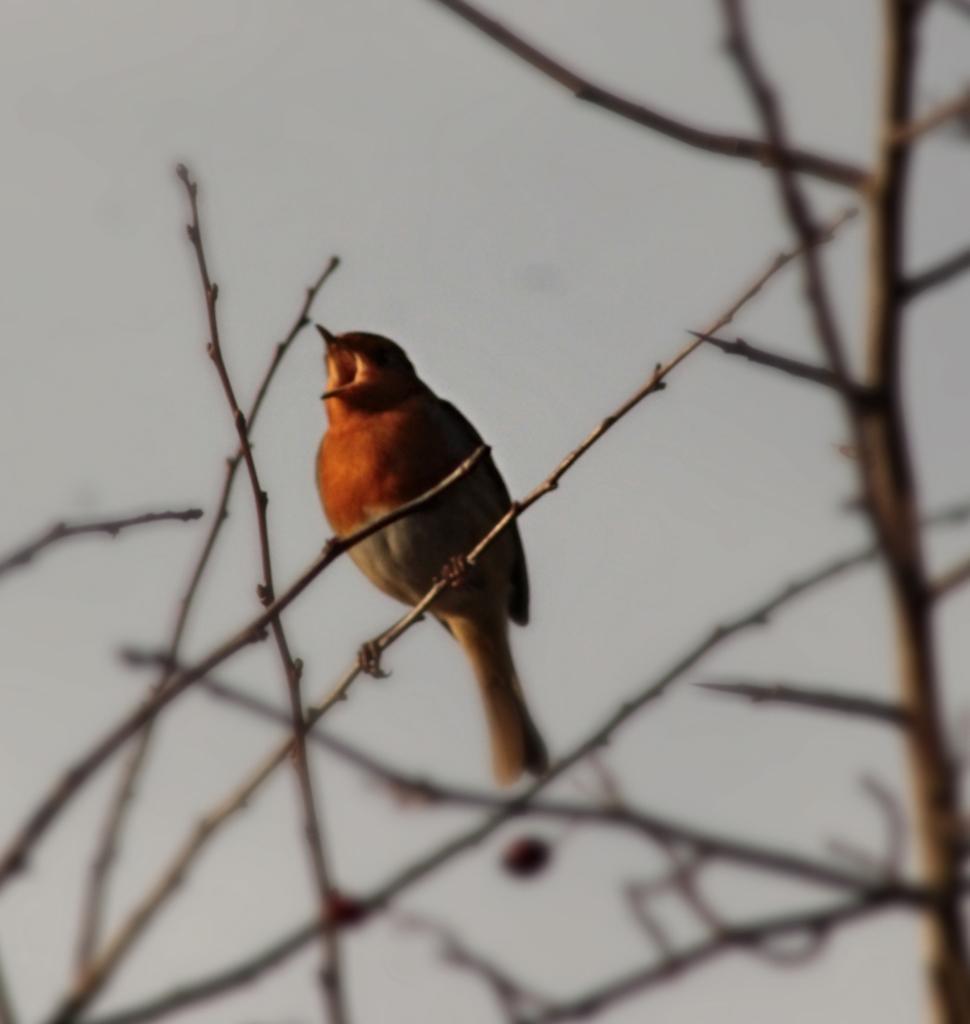Describe this image in one or two sentences. In this picture we can see a bird on the branch. On the right side of the image there is a tree. Behind the bird there is the sky. 